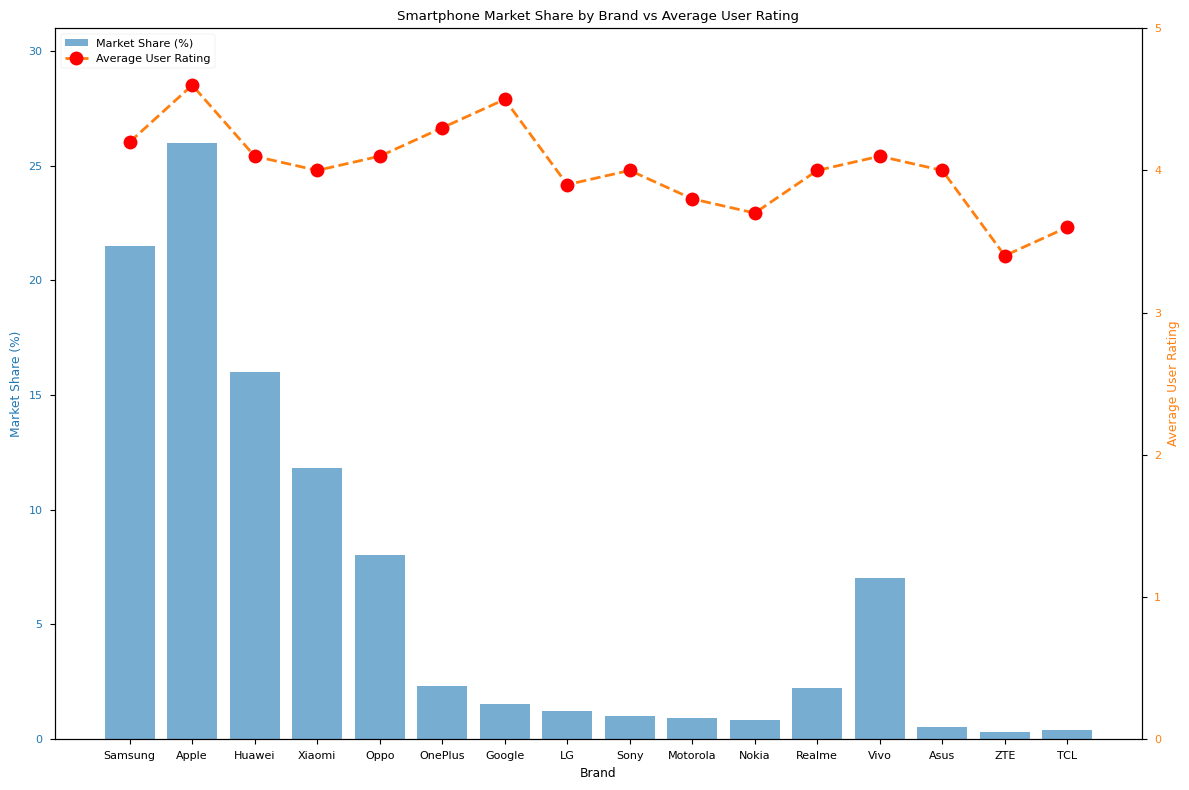What brand has the highest market share? The brand with the tallest blue bar represents the highest market share. From the chart, Apple's bar is the highest.
Answer: Apple Which brand has the lowest average user rating? The brand with the lowest point on the orange dashed line represents the lowest average rating. From the chart, ZTE's point is the lowest.
Answer: ZTE What is the market share difference between the brands with the highest and lowest average user ratings? The highest rating is for Apple (26.0% market share) and the lowest is for ZTE (0.3% market share). The difference is 26.0% - 0.3%.
Answer: 25.7% Which brand has the closest market share to 10%? Look for the blue bar that is closest to the 10% mark on the y-axis. Xiaomi's market share is 11.8%, which is closest.
Answer: Xiaomi Do Samsung and OnePlus have similar user ratings? Compare the positions of the orange points representing Samsung and OnePlus. Samsung has a rating of 4.2 and OnePlus has 4.3, which are quite close.
Answer: Yes How does the market share of OnePlus compare to Google's? Compare the heights of the blue bars for OnePlus and Google. OnePlus has a higher market share (2.3%) compared to Google (1.5%).
Answer: OnePlus has a higher market share What is the market share sum of all brands with an average user rating of 4.0 or above? Add up the market shares for brands with user ratings of 4.0 or above (Samsung, Apple, Huawei, Xiaomi, Oppo, OnePlus, Google, Sony, Vivo, Asus, Realme). The total is 21.5 + 26.0 + 16.0 + 11.8 + 8.0 + 2.3 + 1.5 + 1.0 + 7.0 + 0.5 + 2.2 = 97.8%.
Answer: 97.8% Which brand has the highest user rating but a market share less than 2%? Look for the highest point on the orange dashed line among brands with blue bars shorter than the 2% mark. Google has a rating of 4.5 and a market share of 1.5%.
Answer: Google Are there more brands with a market share above 10% or below 2%? Count the number of blue bars above the 10% mark (Samsung, Apple, Huawei, Xiaomi) and below the 2% mark (OnePlus, Google, LG, Sony, Motorola, Nokia, Asus, ZTE, TCL). There are 4 brands above 10% and 8 brands below 2%.
Answer: Below 2% Which brand has a higher market share, Xiaomi or Oppo, and by how much? Compare the heights of the blue bars for Xiaomi (11.8%) and Oppo (8.0%). Subtract to find the difference: 11.8% - 8.0%.
Answer: Xiaomi by 3.8% 